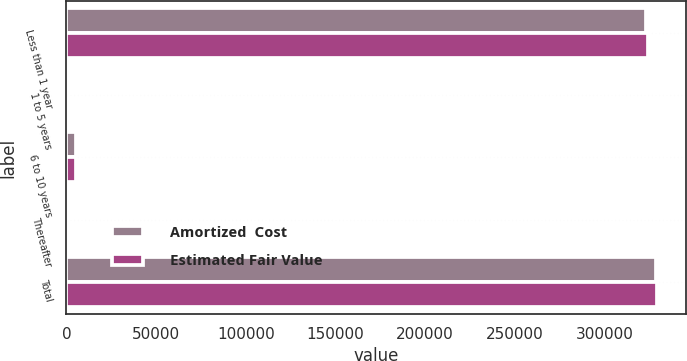Convert chart to OTSL. <chart><loc_0><loc_0><loc_500><loc_500><stacked_bar_chart><ecel><fcel>Less than 1 year<fcel>1 to 5 years<fcel>6 to 10 years<fcel>Thereafter<fcel>Total<nl><fcel>Amortized  Cost<fcel>323210<fcel>0<fcel>5586<fcel>0<fcel>328796<nl><fcel>Estimated Fair Value<fcel>324140<fcel>0<fcel>5195<fcel>0<fcel>329335<nl></chart> 